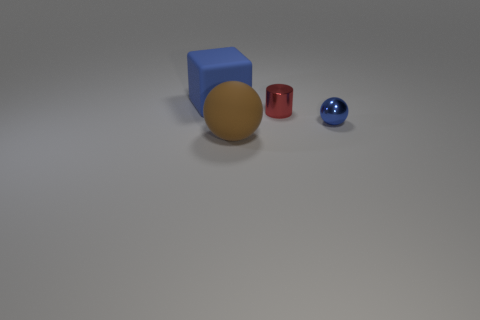There is a blue ball that is the same size as the red shiny cylinder; what is its material? The blue object appears to be a sphere, not a ball, and based on its appearance, which includes a distinct reflective surface and smooth texture, it could be made of a polished metal or a synthetic material with metallic-like properties. 